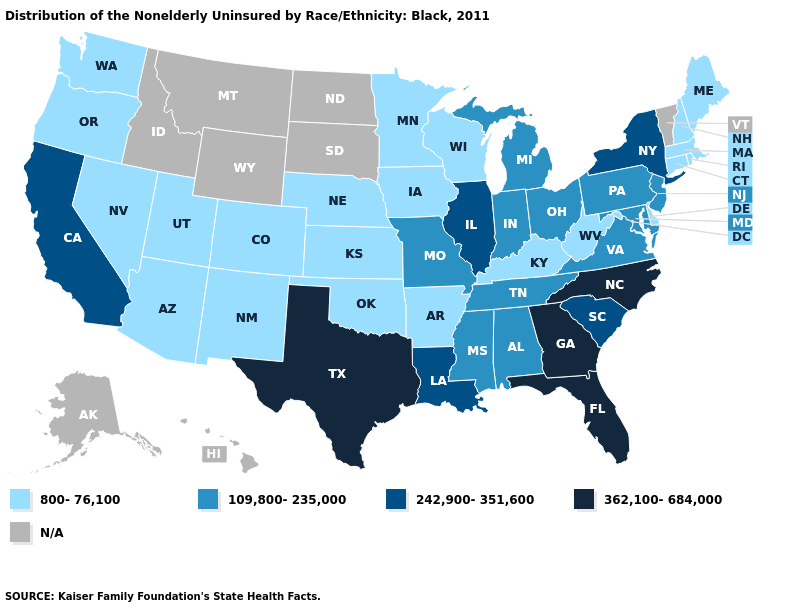Is the legend a continuous bar?
Concise answer only. No. Which states have the lowest value in the USA?
Answer briefly. Arizona, Arkansas, Colorado, Connecticut, Delaware, Iowa, Kansas, Kentucky, Maine, Massachusetts, Minnesota, Nebraska, Nevada, New Hampshire, New Mexico, Oklahoma, Oregon, Rhode Island, Utah, Washington, West Virginia, Wisconsin. What is the highest value in states that border Vermont?
Give a very brief answer. 242,900-351,600. Does Colorado have the lowest value in the USA?
Keep it brief. Yes. How many symbols are there in the legend?
Concise answer only. 5. What is the value of Alabama?
Keep it brief. 109,800-235,000. Name the states that have a value in the range 362,100-684,000?
Quick response, please. Florida, Georgia, North Carolina, Texas. What is the value of Pennsylvania?
Keep it brief. 109,800-235,000. Name the states that have a value in the range 362,100-684,000?
Write a very short answer. Florida, Georgia, North Carolina, Texas. What is the value of Vermont?
Concise answer only. N/A. What is the highest value in the USA?
Concise answer only. 362,100-684,000. Name the states that have a value in the range 362,100-684,000?
Give a very brief answer. Florida, Georgia, North Carolina, Texas. Name the states that have a value in the range 242,900-351,600?
Short answer required. California, Illinois, Louisiana, New York, South Carolina. Which states have the highest value in the USA?
Answer briefly. Florida, Georgia, North Carolina, Texas. What is the value of Wyoming?
Give a very brief answer. N/A. 